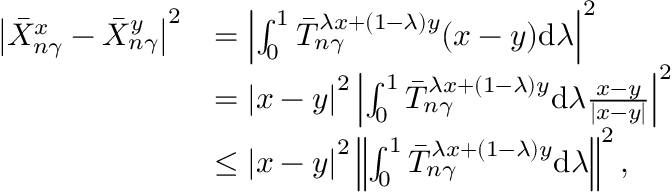<formula> <loc_0><loc_0><loc_500><loc_500>\begin{array} { r l } { \left | \bar { X } _ { n \gamma } ^ { x } - \bar { X } _ { n \gamma } ^ { y } \right | ^ { 2 } } & { = \left | \int _ { 0 } ^ { 1 } \bar { T } _ { n \gamma } ^ { \lambda x + ( 1 - \lambda ) y } ( x - y ) d \lambda \right | ^ { 2 } } \\ & { = \left | x - y \right | ^ { 2 } \left | \int _ { 0 } ^ { 1 } \bar { T } _ { n \gamma } ^ { \lambda x + ( 1 - \lambda ) y } d \lambda \frac { x - y } { \left | x - y \right | } \right | ^ { 2 } } \\ & { \leq \left | x - y \right | ^ { 2 } \left \| \int _ { 0 } ^ { 1 } \bar { T } _ { n \gamma } ^ { \lambda x + ( 1 - \lambda ) y } d \lambda \right \| ^ { 2 } , } \end{array}</formula> 